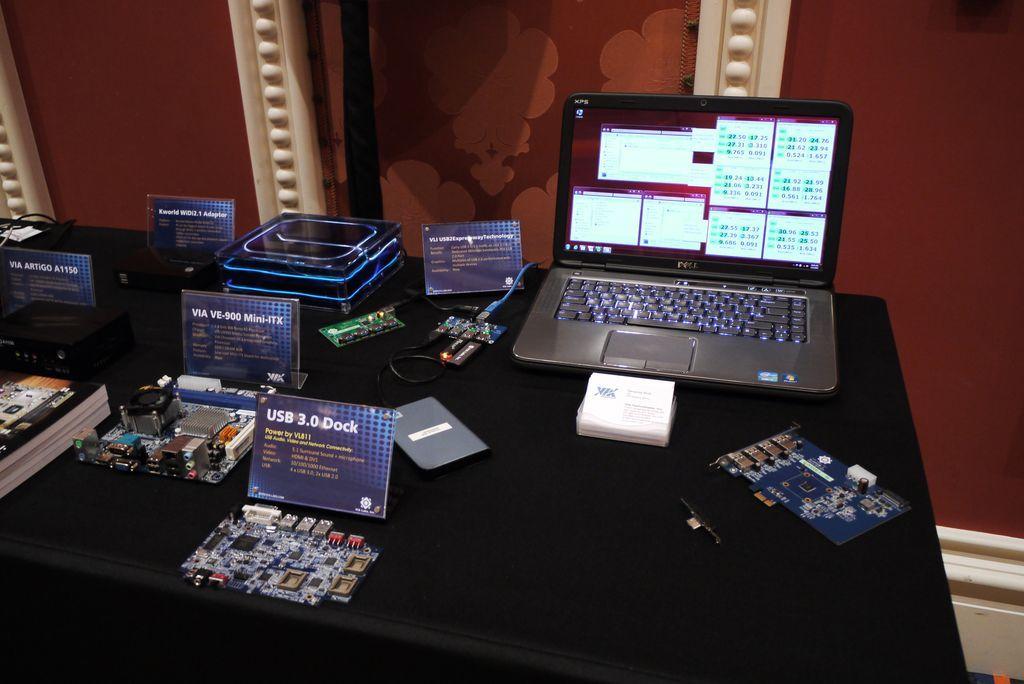What brand of laptop is this?
Give a very brief answer. Dell. What usb is being displayed?
Your answer should be very brief. 3.0 dock. 